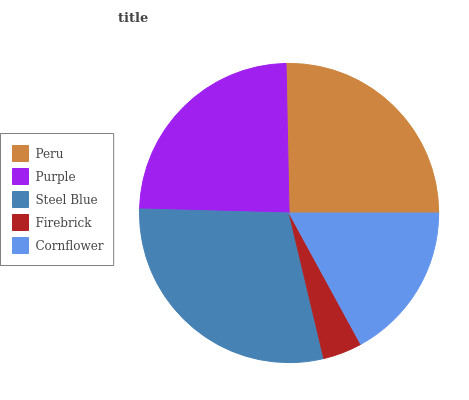Is Firebrick the minimum?
Answer yes or no. Yes. Is Steel Blue the maximum?
Answer yes or no. Yes. Is Purple the minimum?
Answer yes or no. No. Is Purple the maximum?
Answer yes or no. No. Is Peru greater than Purple?
Answer yes or no. Yes. Is Purple less than Peru?
Answer yes or no. Yes. Is Purple greater than Peru?
Answer yes or no. No. Is Peru less than Purple?
Answer yes or no. No. Is Purple the high median?
Answer yes or no. Yes. Is Purple the low median?
Answer yes or no. Yes. Is Peru the high median?
Answer yes or no. No. Is Cornflower the low median?
Answer yes or no. No. 